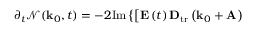Convert formula to latex. <formula><loc_0><loc_0><loc_500><loc_500>\partial _ { t } \mathcal { N } ( k _ { 0 } , t ) = - 2 I m \left \{ \left [ E \left ( t \right ) D _ { t r } \left ( k _ { 0 } + A \right )</formula> 